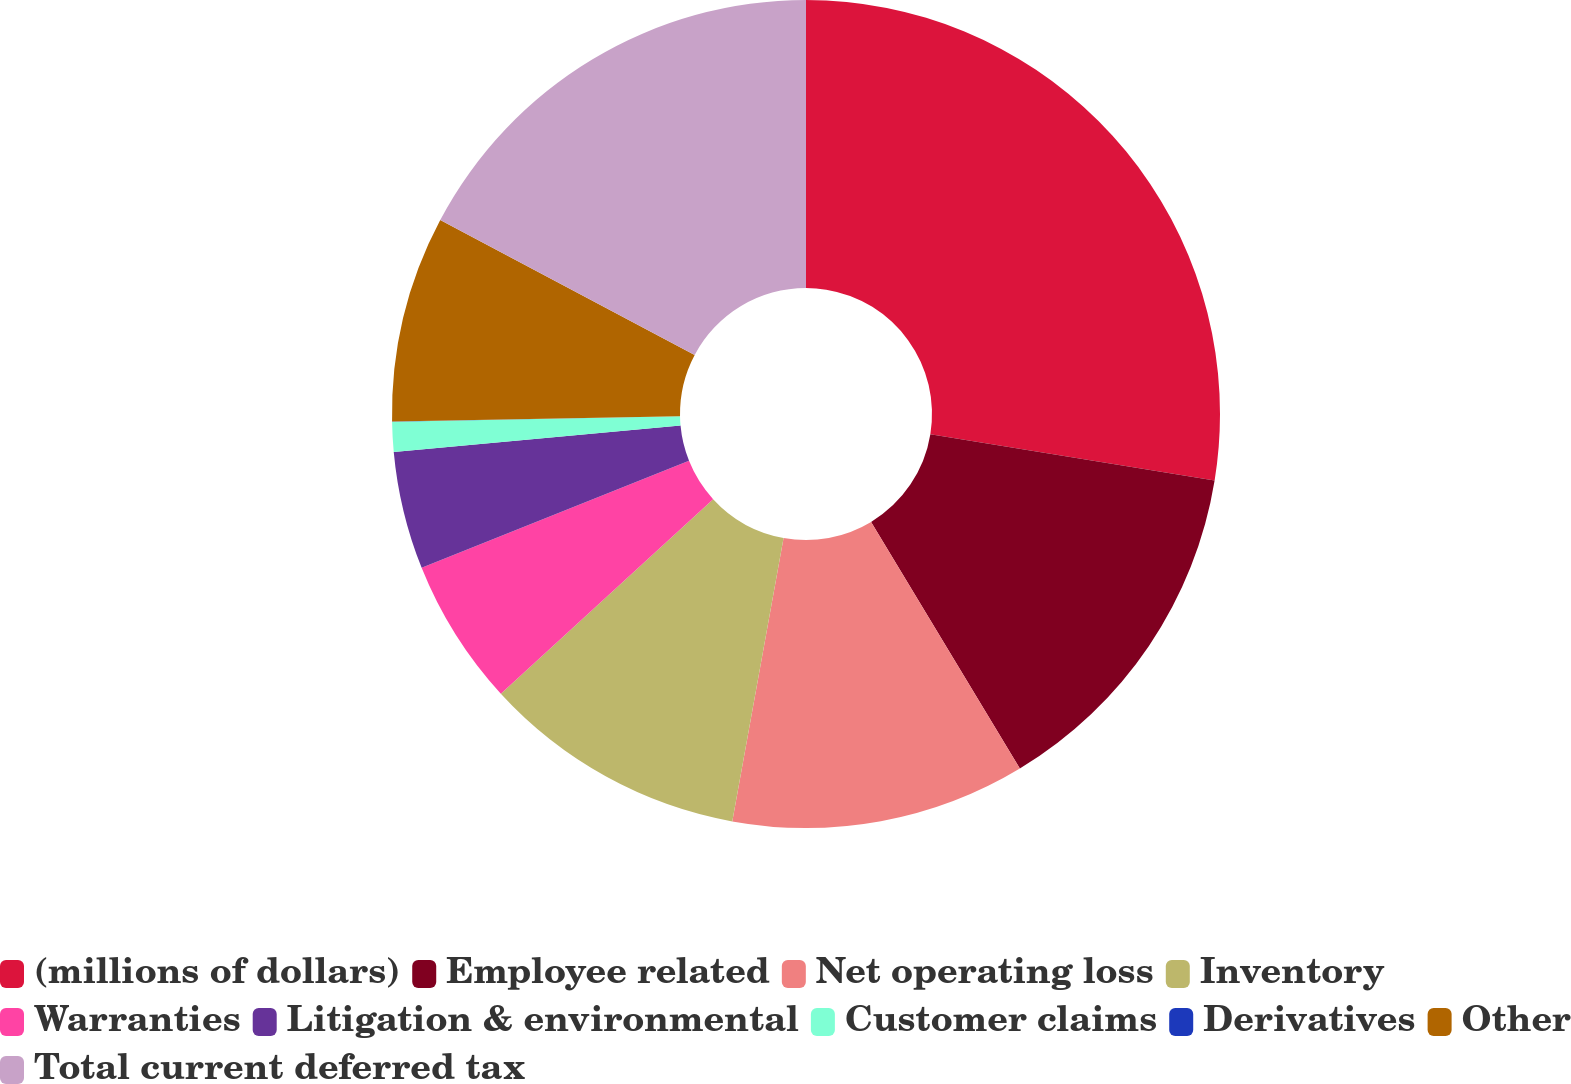<chart> <loc_0><loc_0><loc_500><loc_500><pie_chart><fcel>(millions of dollars)<fcel>Employee related<fcel>Net operating loss<fcel>Inventory<fcel>Warranties<fcel>Litigation & environmental<fcel>Customer claims<fcel>Derivatives<fcel>Other<fcel>Total current deferred tax<nl><fcel>27.57%<fcel>13.79%<fcel>11.49%<fcel>10.34%<fcel>5.75%<fcel>4.6%<fcel>1.16%<fcel>0.01%<fcel>8.05%<fcel>17.24%<nl></chart> 